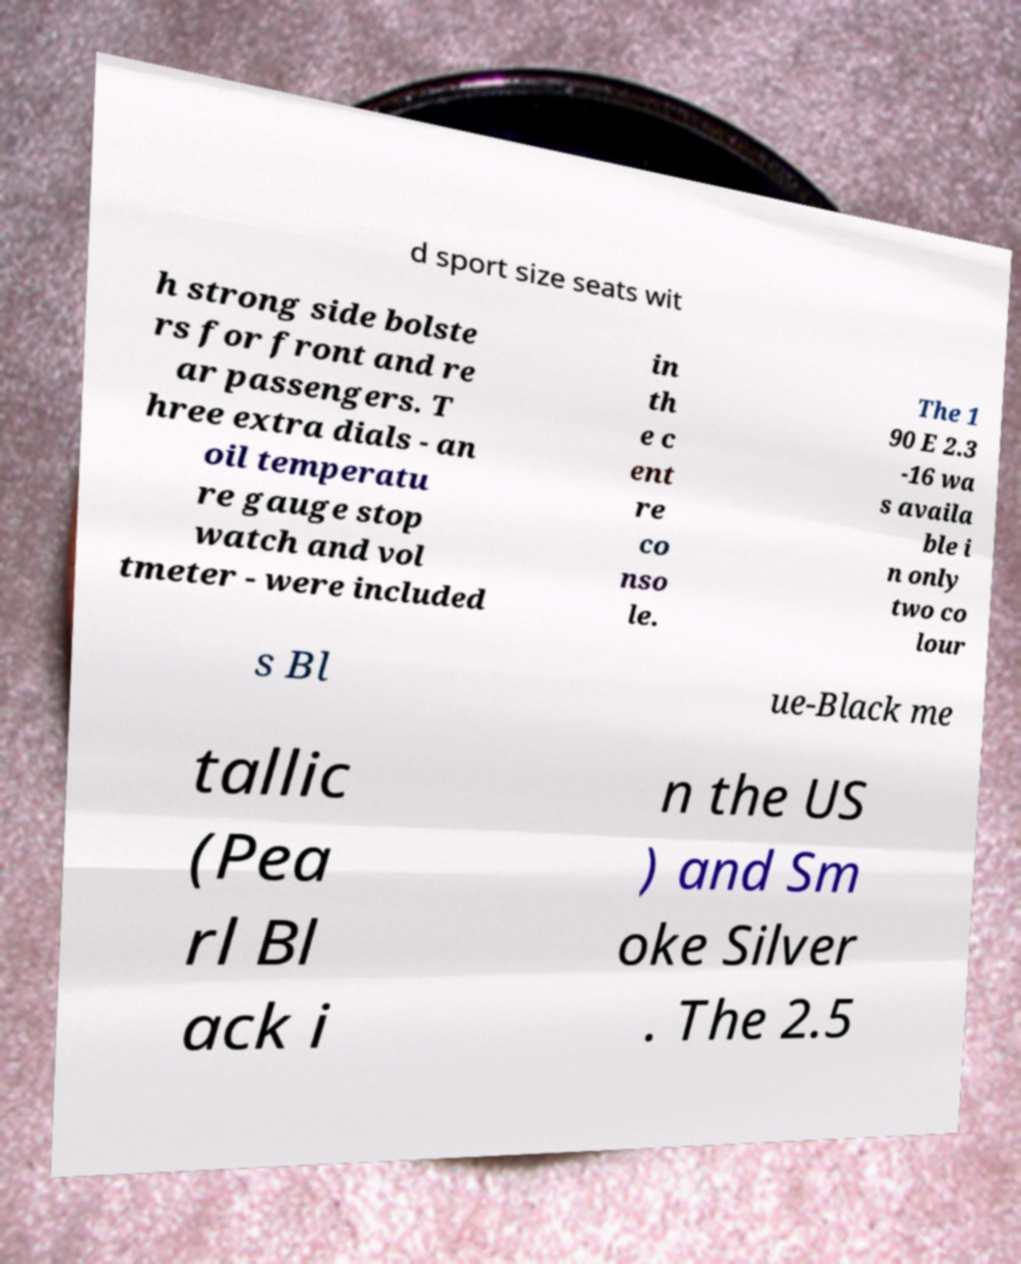There's text embedded in this image that I need extracted. Can you transcribe it verbatim? d sport size seats wit h strong side bolste rs for front and re ar passengers. T hree extra dials - an oil temperatu re gauge stop watch and vol tmeter - were included in th e c ent re co nso le. The 1 90 E 2.3 -16 wa s availa ble i n only two co lour s Bl ue-Black me tallic (Pea rl Bl ack i n the US ) and Sm oke Silver . The 2.5 